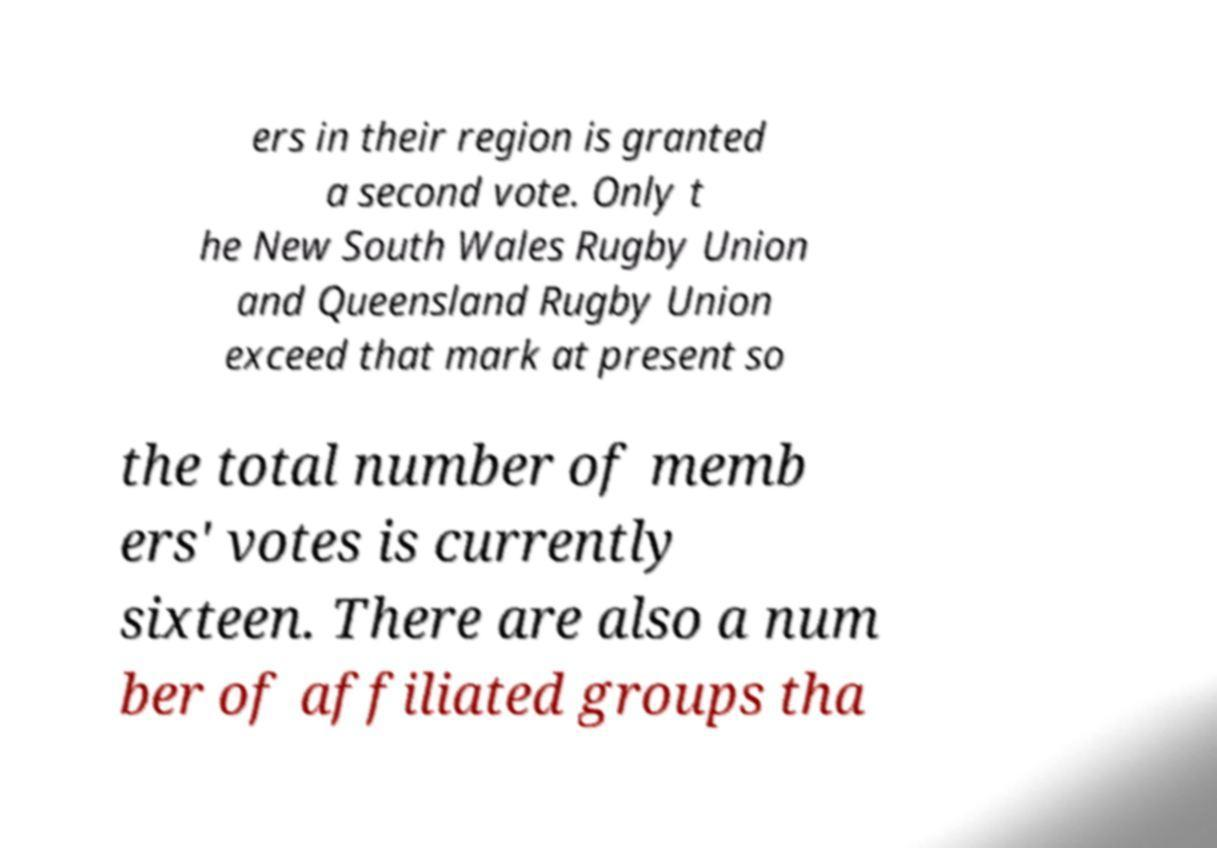For documentation purposes, I need the text within this image transcribed. Could you provide that? ers in their region is granted a second vote. Only t he New South Wales Rugby Union and Queensland Rugby Union exceed that mark at present so the total number of memb ers' votes is currently sixteen. There are also a num ber of affiliated groups tha 